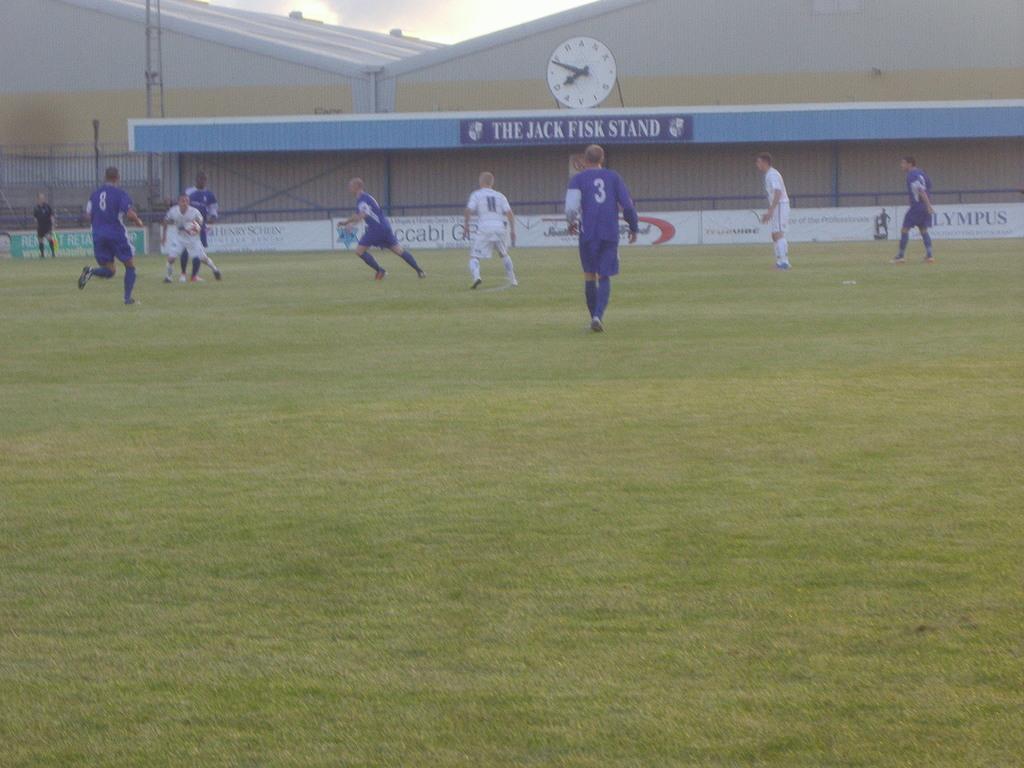What is the name of the stand in the background?
Provide a succinct answer. The jack fisk stand. Who is the stand named after?
Offer a very short reply. Jack fisk. 